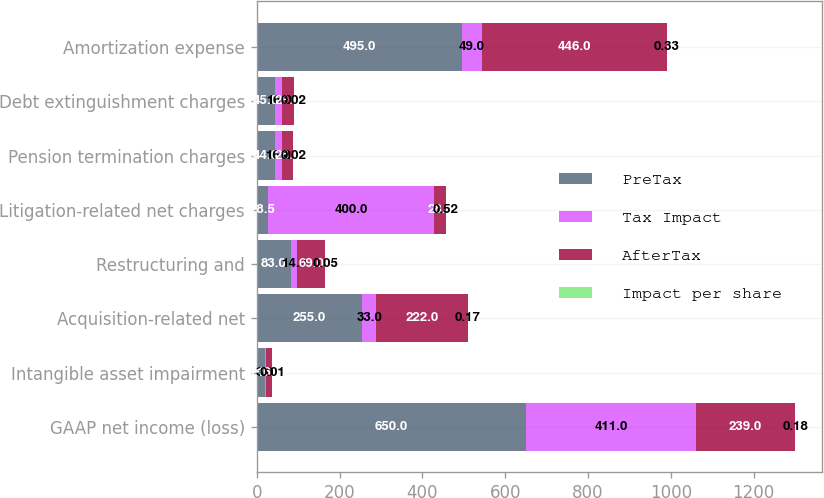Convert chart to OTSL. <chart><loc_0><loc_0><loc_500><loc_500><stacked_bar_chart><ecel><fcel>GAAP net income (loss)<fcel>Intangible asset impairment<fcel>Acquisition-related net<fcel>Restructuring and<fcel>Litigation-related net charges<fcel>Pension termination charges<fcel>Debt extinguishment charges<fcel>Amortization expense<nl><fcel>PreTax<fcel>650<fcel>19<fcel>255<fcel>83<fcel>28.5<fcel>44<fcel>45<fcel>495<nl><fcel>Tax Impact<fcel>411<fcel>3<fcel>33<fcel>14<fcel>400<fcel>16<fcel>16<fcel>49<nl><fcel>AfterTax<fcel>239<fcel>16<fcel>222<fcel>69<fcel>28.5<fcel>28<fcel>29<fcel>446<nl><fcel>Impact per share<fcel>0.18<fcel>0.01<fcel>0.17<fcel>0.05<fcel>0.52<fcel>0.02<fcel>0.02<fcel>0.33<nl></chart> 